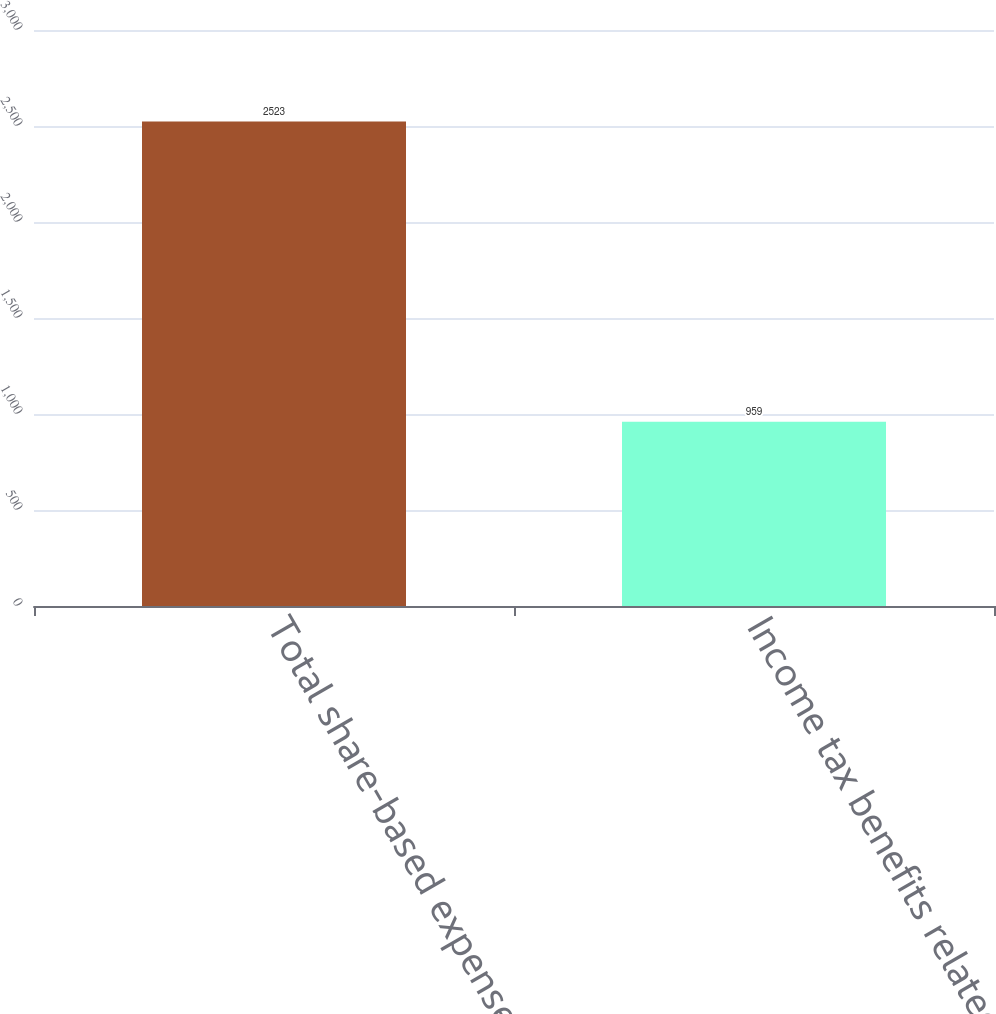Convert chart. <chart><loc_0><loc_0><loc_500><loc_500><bar_chart><fcel>Total share-based expense<fcel>Income tax benefits related to<nl><fcel>2523<fcel>959<nl></chart> 